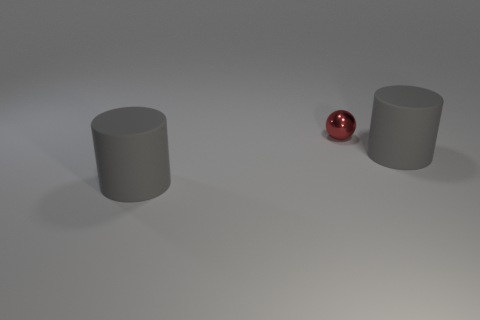What is the color of the tiny shiny ball? red 